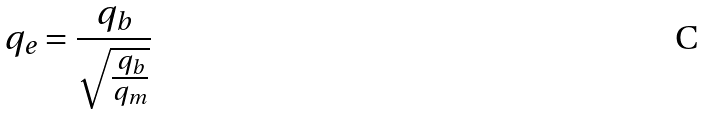Convert formula to latex. <formula><loc_0><loc_0><loc_500><loc_500>q _ { e } = \frac { q _ { b } } { \sqrt { \frac { q _ { b } } { q _ { m } } } }</formula> 